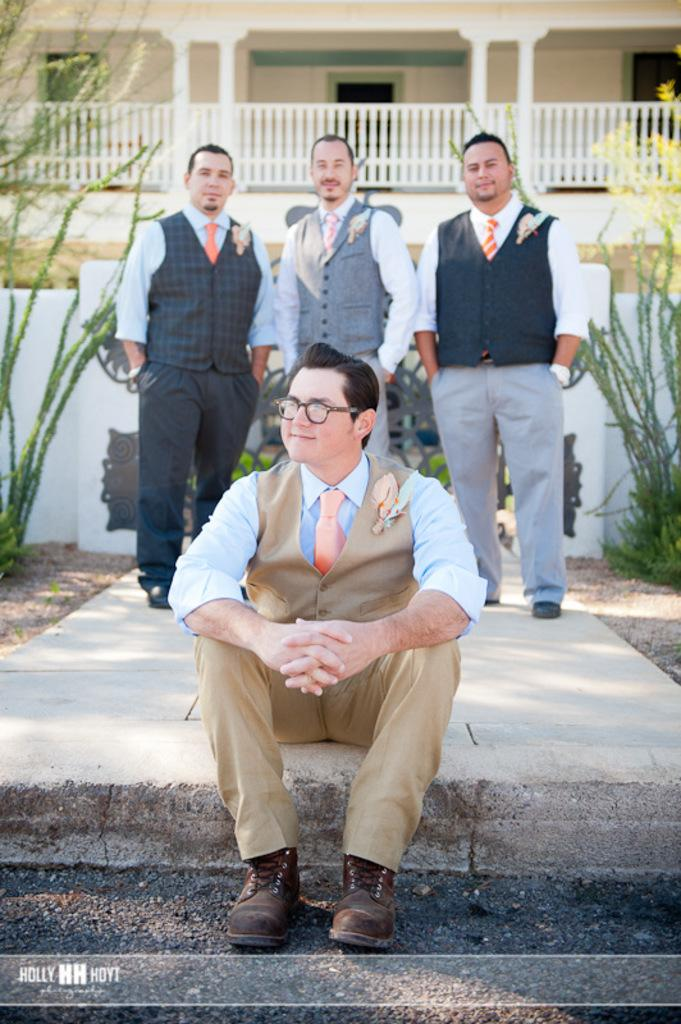How many men are present in the image? There are three men standing in the image, and one man sitting on the floor, making a total of four men. What are the men in the image doing? The men are standing or sitting, but their specific actions are not clear from the image. What can be seen in the background of the image? There are buildings, a concrete grill, sand, walls, and plants in the background of the image. Can you hear the whistle of the wind in the image? There is no information about the wind or any whistling sound in the image, so we cannot determine if it is present or not. 